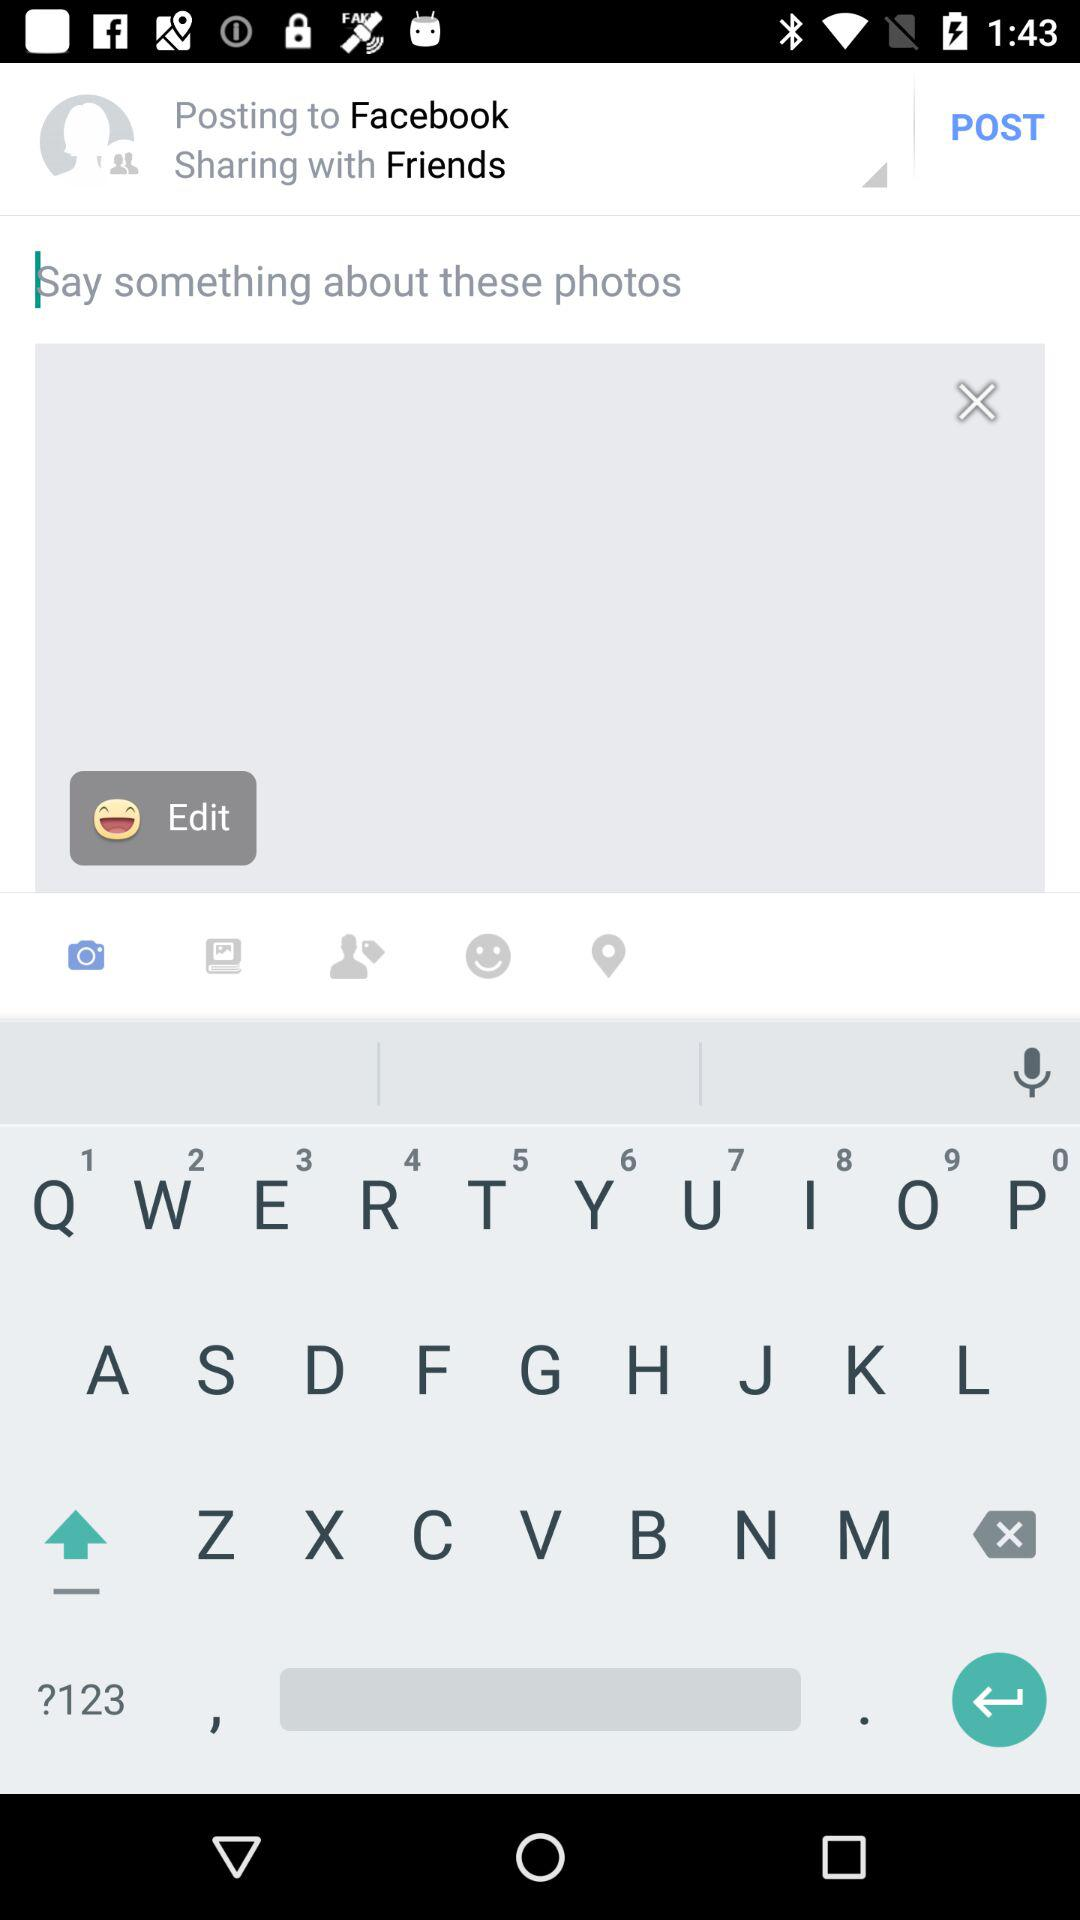What is the selected app for posting? The selected app is "Facebook". 